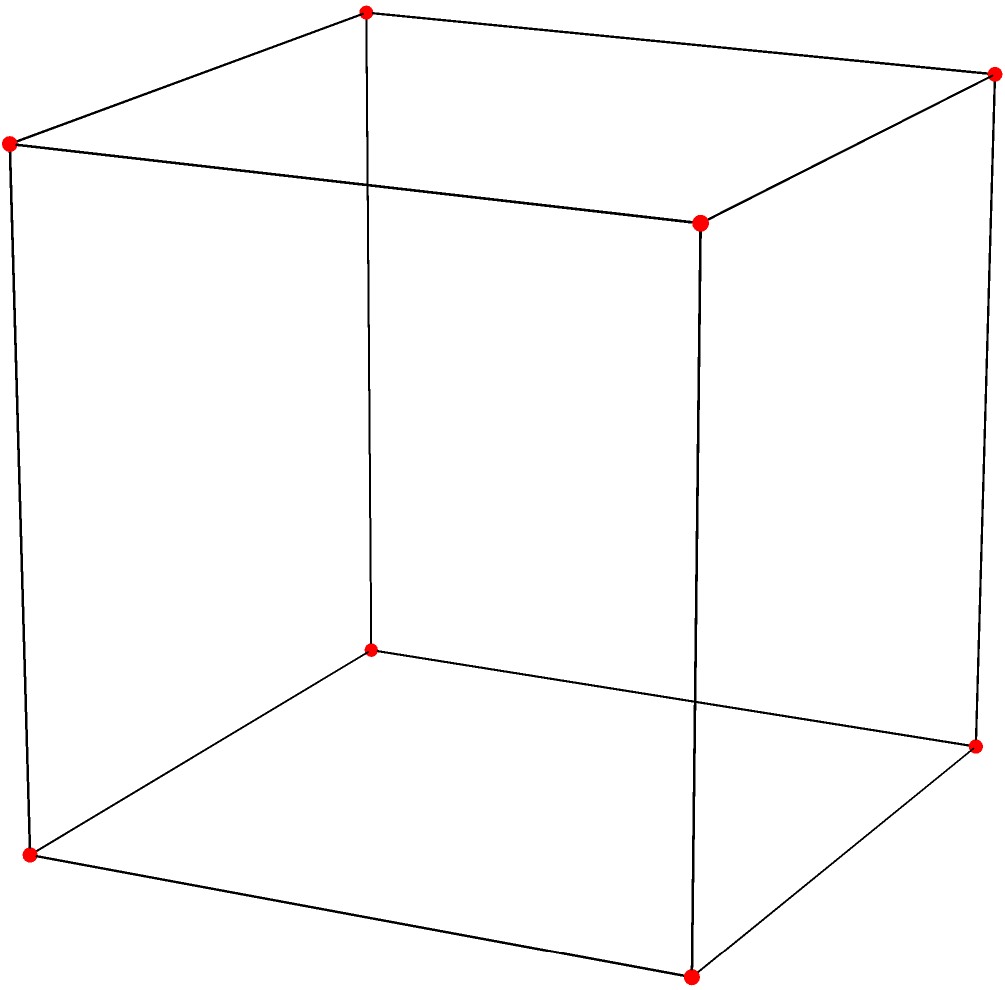In a cube, a new edge is added connecting opposite vertices (as shown in blue). How does this affect the Euler characteristic of the polyhedron? Calculate the new Euler characteristic. Let's approach this step-by-step:

1) First, recall the Euler characteristic formula:
   $$V - E + F = 2$$
   where $V$ is the number of vertices, $E$ is the number of edges, and $F$ is the number of faces.

2) For a regular cube:
   - Vertices (V): 8
   - Edges (E): 12
   - Faces (F): 6
   
3) Let's verify the Euler characteristic for the original cube:
   $$8 - 12 + 6 = 2$$

4) Now, we've added a new edge (the blue diagonal). This doesn't change the number of vertices or faces, but it increases the number of edges by 1.

5) The new counts are:
   - Vertices (V): 8 (unchanged)
   - Edges (E): 13 (12 + 1)
   - Faces (F): 6 (unchanged)

6) Let's calculate the new Euler characteristic:
   $$V - E + F = 8 - 13 + 6 = 1$$

7) The Euler characteristic has changed from 2 to 1.

This makes sense topologically, as adding this internal edge is equivalent to adding a handle to the surface of the cube, changing its genus and thus its Euler characteristic.
Answer: 1 